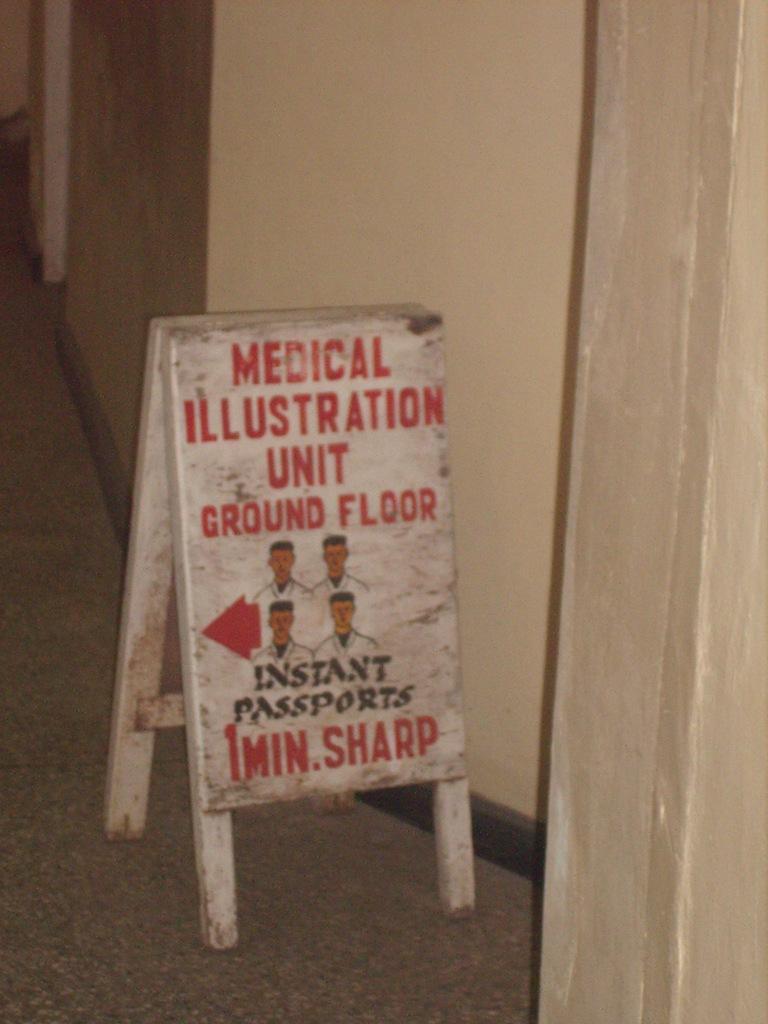Describe this image in one or two sentences. In this image in the front there is a board with some text written on it. On the right side there is a curtain. In the background there is a wall. 